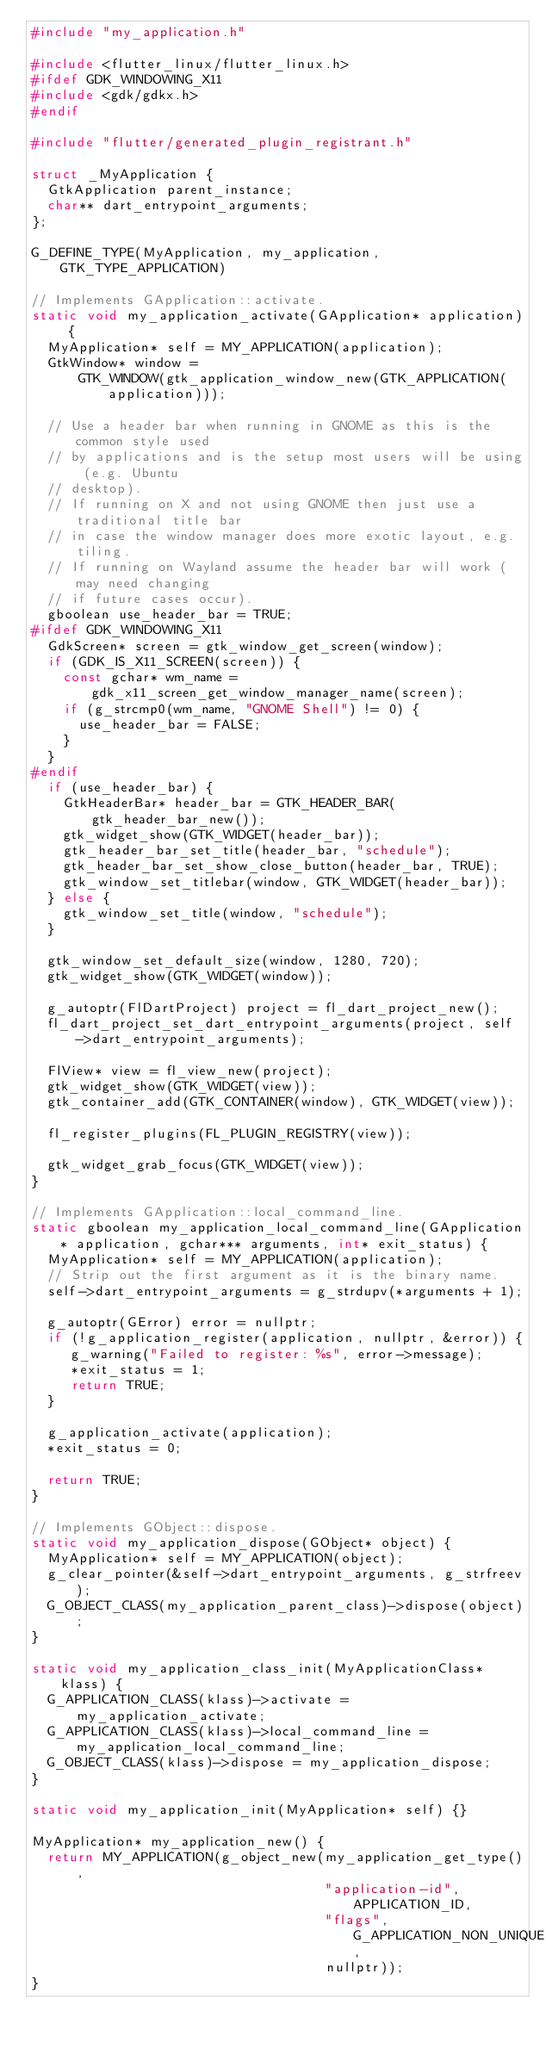<code> <loc_0><loc_0><loc_500><loc_500><_C++_>#include "my_application.h"

#include <flutter_linux/flutter_linux.h>
#ifdef GDK_WINDOWING_X11
#include <gdk/gdkx.h>
#endif

#include "flutter/generated_plugin_registrant.h"

struct _MyApplication {
  GtkApplication parent_instance;
  char** dart_entrypoint_arguments;
};

G_DEFINE_TYPE(MyApplication, my_application, GTK_TYPE_APPLICATION)

// Implements GApplication::activate.
static void my_application_activate(GApplication* application) {
  MyApplication* self = MY_APPLICATION(application);
  GtkWindow* window =
      GTK_WINDOW(gtk_application_window_new(GTK_APPLICATION(application)));

  // Use a header bar when running in GNOME as this is the common style used
  // by applications and is the setup most users will be using (e.g. Ubuntu
  // desktop).
  // If running on X and not using GNOME then just use a traditional title bar
  // in case the window manager does more exotic layout, e.g. tiling.
  // If running on Wayland assume the header bar will work (may need changing
  // if future cases occur).
  gboolean use_header_bar = TRUE;
#ifdef GDK_WINDOWING_X11
  GdkScreen* screen = gtk_window_get_screen(window);
  if (GDK_IS_X11_SCREEN(screen)) {
    const gchar* wm_name = gdk_x11_screen_get_window_manager_name(screen);
    if (g_strcmp0(wm_name, "GNOME Shell") != 0) {
      use_header_bar = FALSE;
    }
  }
#endif
  if (use_header_bar) {
    GtkHeaderBar* header_bar = GTK_HEADER_BAR(gtk_header_bar_new());
    gtk_widget_show(GTK_WIDGET(header_bar));
    gtk_header_bar_set_title(header_bar, "schedule");
    gtk_header_bar_set_show_close_button(header_bar, TRUE);
    gtk_window_set_titlebar(window, GTK_WIDGET(header_bar));
  } else {
    gtk_window_set_title(window, "schedule");
  }

  gtk_window_set_default_size(window, 1280, 720);
  gtk_widget_show(GTK_WIDGET(window));

  g_autoptr(FlDartProject) project = fl_dart_project_new();
  fl_dart_project_set_dart_entrypoint_arguments(project, self->dart_entrypoint_arguments);

  FlView* view = fl_view_new(project);
  gtk_widget_show(GTK_WIDGET(view));
  gtk_container_add(GTK_CONTAINER(window), GTK_WIDGET(view));

  fl_register_plugins(FL_PLUGIN_REGISTRY(view));

  gtk_widget_grab_focus(GTK_WIDGET(view));
}

// Implements GApplication::local_command_line.
static gboolean my_application_local_command_line(GApplication* application, gchar*** arguments, int* exit_status) {
  MyApplication* self = MY_APPLICATION(application);
  // Strip out the first argument as it is the binary name.
  self->dart_entrypoint_arguments = g_strdupv(*arguments + 1);

  g_autoptr(GError) error = nullptr;
  if (!g_application_register(application, nullptr, &error)) {
     g_warning("Failed to register: %s", error->message);
     *exit_status = 1;
     return TRUE;
  }

  g_application_activate(application);
  *exit_status = 0;

  return TRUE;
}

// Implements GObject::dispose.
static void my_application_dispose(GObject* object) {
  MyApplication* self = MY_APPLICATION(object);
  g_clear_pointer(&self->dart_entrypoint_arguments, g_strfreev);
  G_OBJECT_CLASS(my_application_parent_class)->dispose(object);
}

static void my_application_class_init(MyApplicationClass* klass) {
  G_APPLICATION_CLASS(klass)->activate = my_application_activate;
  G_APPLICATION_CLASS(klass)->local_command_line = my_application_local_command_line;
  G_OBJECT_CLASS(klass)->dispose = my_application_dispose;
}

static void my_application_init(MyApplication* self) {}

MyApplication* my_application_new() {
  return MY_APPLICATION(g_object_new(my_application_get_type(),
                                     "application-id", APPLICATION_ID,
                                     "flags", G_APPLICATION_NON_UNIQUE,
                                     nullptr));
}
</code> 